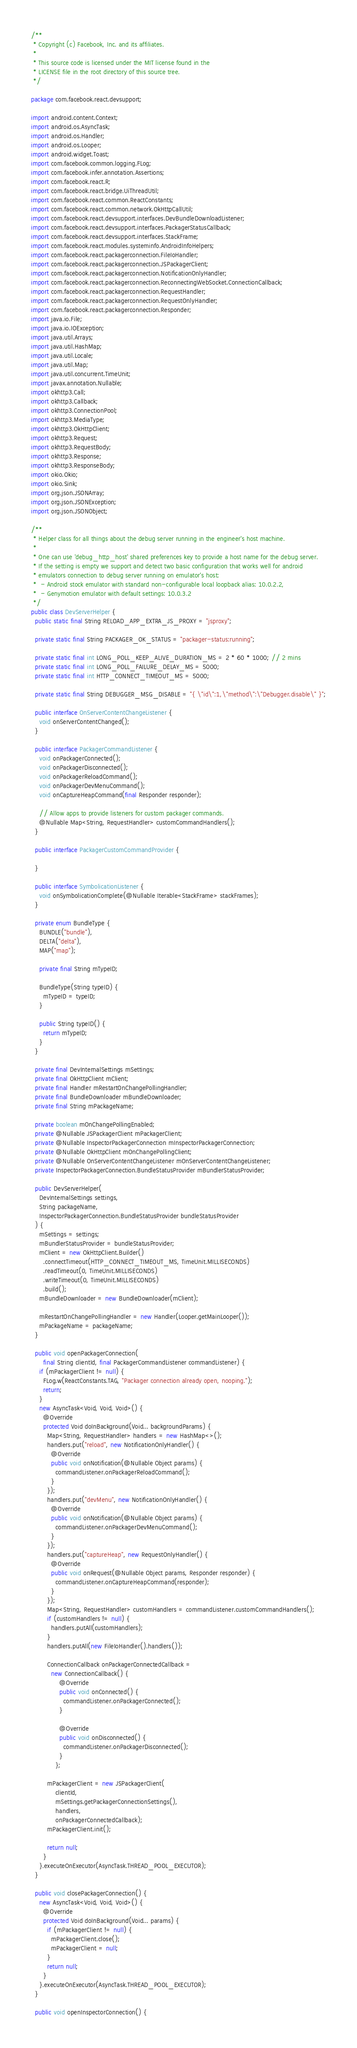Convert code to text. <code><loc_0><loc_0><loc_500><loc_500><_Java_>/**
 * Copyright (c) Facebook, Inc. and its affiliates.
 *
 * This source code is licensed under the MIT license found in the
 * LICENSE file in the root directory of this source tree.
 */

package com.facebook.react.devsupport;

import android.content.Context;
import android.os.AsyncTask;
import android.os.Handler;
import android.os.Looper;
import android.widget.Toast;
import com.facebook.common.logging.FLog;
import com.facebook.infer.annotation.Assertions;
import com.facebook.react.R;
import com.facebook.react.bridge.UiThreadUtil;
import com.facebook.react.common.ReactConstants;
import com.facebook.react.common.network.OkHttpCallUtil;
import com.facebook.react.devsupport.interfaces.DevBundleDownloadListener;
import com.facebook.react.devsupport.interfaces.PackagerStatusCallback;
import com.facebook.react.devsupport.interfaces.StackFrame;
import com.facebook.react.modules.systeminfo.AndroidInfoHelpers;
import com.facebook.react.packagerconnection.FileIoHandler;
import com.facebook.react.packagerconnection.JSPackagerClient;
import com.facebook.react.packagerconnection.NotificationOnlyHandler;
import com.facebook.react.packagerconnection.ReconnectingWebSocket.ConnectionCallback;
import com.facebook.react.packagerconnection.RequestHandler;
import com.facebook.react.packagerconnection.RequestOnlyHandler;
import com.facebook.react.packagerconnection.Responder;
import java.io.File;
import java.io.IOException;
import java.util.Arrays;
import java.util.HashMap;
import java.util.Locale;
import java.util.Map;
import java.util.concurrent.TimeUnit;
import javax.annotation.Nullable;
import okhttp3.Call;
import okhttp3.Callback;
import okhttp3.ConnectionPool;
import okhttp3.MediaType;
import okhttp3.OkHttpClient;
import okhttp3.Request;
import okhttp3.RequestBody;
import okhttp3.Response;
import okhttp3.ResponseBody;
import okio.Okio;
import okio.Sink;
import org.json.JSONArray;
import org.json.JSONException;
import org.json.JSONObject;

/**
 * Helper class for all things about the debug server running in the engineer's host machine.
 *
 * One can use 'debug_http_host' shared preferences key to provide a host name for the debug server.
 * If the setting is empty we support and detect two basic configuration that works well for android
 * emulators connection to debug server running on emulator's host:
 *  - Android stock emulator with standard non-configurable local loopback alias: 10.0.2.2,
 *  - Genymotion emulator with default settings: 10.0.3.2
 */
public class DevServerHelper {
  public static final String RELOAD_APP_EXTRA_JS_PROXY = "jsproxy";

  private static final String PACKAGER_OK_STATUS = "packager-status:running";

  private static final int LONG_POLL_KEEP_ALIVE_DURATION_MS = 2 * 60 * 1000; // 2 mins
  private static final int LONG_POLL_FAILURE_DELAY_MS = 5000;
  private static final int HTTP_CONNECT_TIMEOUT_MS = 5000;

  private static final String DEBUGGER_MSG_DISABLE = "{ \"id\":1,\"method\":\"Debugger.disable\" }";

  public interface OnServerContentChangeListener {
    void onServerContentChanged();
  }

  public interface PackagerCommandListener {
    void onPackagerConnected();
    void onPackagerDisconnected();
    void onPackagerReloadCommand();
    void onPackagerDevMenuCommand();
    void onCaptureHeapCommand(final Responder responder);

    // Allow apps to provide listeners for custom packager commands.
    @Nullable Map<String, RequestHandler> customCommandHandlers();
  }

  public interface PackagerCustomCommandProvider {

  }

  public interface SymbolicationListener {
    void onSymbolicationComplete(@Nullable Iterable<StackFrame> stackFrames);
  }

  private enum BundleType {
    BUNDLE("bundle"),
    DELTA("delta"),
    MAP("map");

    private final String mTypeID;

    BundleType(String typeID) {
      mTypeID = typeID;
    }

    public String typeID() {
      return mTypeID;
    }
  }

  private final DevInternalSettings mSettings;
  private final OkHttpClient mClient;
  private final Handler mRestartOnChangePollingHandler;
  private final BundleDownloader mBundleDownloader;
  private final String mPackageName;

  private boolean mOnChangePollingEnabled;
  private @Nullable JSPackagerClient mPackagerClient;
  private @Nullable InspectorPackagerConnection mInspectorPackagerConnection;
  private @Nullable OkHttpClient mOnChangePollingClient;
  private @Nullable OnServerContentChangeListener mOnServerContentChangeListener;
  private InspectorPackagerConnection.BundleStatusProvider mBundlerStatusProvider;

  public DevServerHelper(
    DevInternalSettings settings,
    String packageName,
    InspectorPackagerConnection.BundleStatusProvider bundleStatusProvider
  ) {
    mSettings = settings;
    mBundlerStatusProvider = bundleStatusProvider;
    mClient = new OkHttpClient.Builder()
      .connectTimeout(HTTP_CONNECT_TIMEOUT_MS, TimeUnit.MILLISECONDS)
      .readTimeout(0, TimeUnit.MILLISECONDS)
      .writeTimeout(0, TimeUnit.MILLISECONDS)
      .build();
    mBundleDownloader = new BundleDownloader(mClient);

    mRestartOnChangePollingHandler = new Handler(Looper.getMainLooper());
    mPackageName = packageName;
  }

  public void openPackagerConnection(
      final String clientId, final PackagerCommandListener commandListener) {
    if (mPackagerClient != null) {
      FLog.w(ReactConstants.TAG, "Packager connection already open, nooping.");
      return;
    }
    new AsyncTask<Void, Void, Void>() {
      @Override
      protected Void doInBackground(Void... backgroundParams) {
        Map<String, RequestHandler> handlers = new HashMap<>();
        handlers.put("reload", new NotificationOnlyHandler() {
          @Override
          public void onNotification(@Nullable Object params) {
            commandListener.onPackagerReloadCommand();
          }
        });
        handlers.put("devMenu", new NotificationOnlyHandler() {
          @Override
          public void onNotification(@Nullable Object params) {
            commandListener.onPackagerDevMenuCommand();
          }
        });
        handlers.put("captureHeap", new RequestOnlyHandler() {
          @Override
          public void onRequest(@Nullable Object params, Responder responder) {
            commandListener.onCaptureHeapCommand(responder);
          }
        });
        Map<String, RequestHandler> customHandlers = commandListener.customCommandHandlers();
        if (customHandlers != null) {
          handlers.putAll(customHandlers);
        }
        handlers.putAll(new FileIoHandler().handlers());

        ConnectionCallback onPackagerConnectedCallback =
          new ConnectionCallback() {
              @Override
              public void onConnected() {
                commandListener.onPackagerConnected();
              }

              @Override
              public void onDisconnected() {
                commandListener.onPackagerDisconnected();
              }
            };

        mPackagerClient = new JSPackagerClient(
            clientId,
            mSettings.getPackagerConnectionSettings(),
            handlers,
            onPackagerConnectedCallback);
        mPackagerClient.init();

        return null;
      }
    }.executeOnExecutor(AsyncTask.THREAD_POOL_EXECUTOR);
  }

  public void closePackagerConnection() {
    new AsyncTask<Void, Void, Void>() {
      @Override
      protected Void doInBackground(Void... params) {
        if (mPackagerClient != null) {
          mPackagerClient.close();
          mPackagerClient = null;
        }
        return null;
      }
    }.executeOnExecutor(AsyncTask.THREAD_POOL_EXECUTOR);
  }

  public void openInspectorConnection() {</code> 